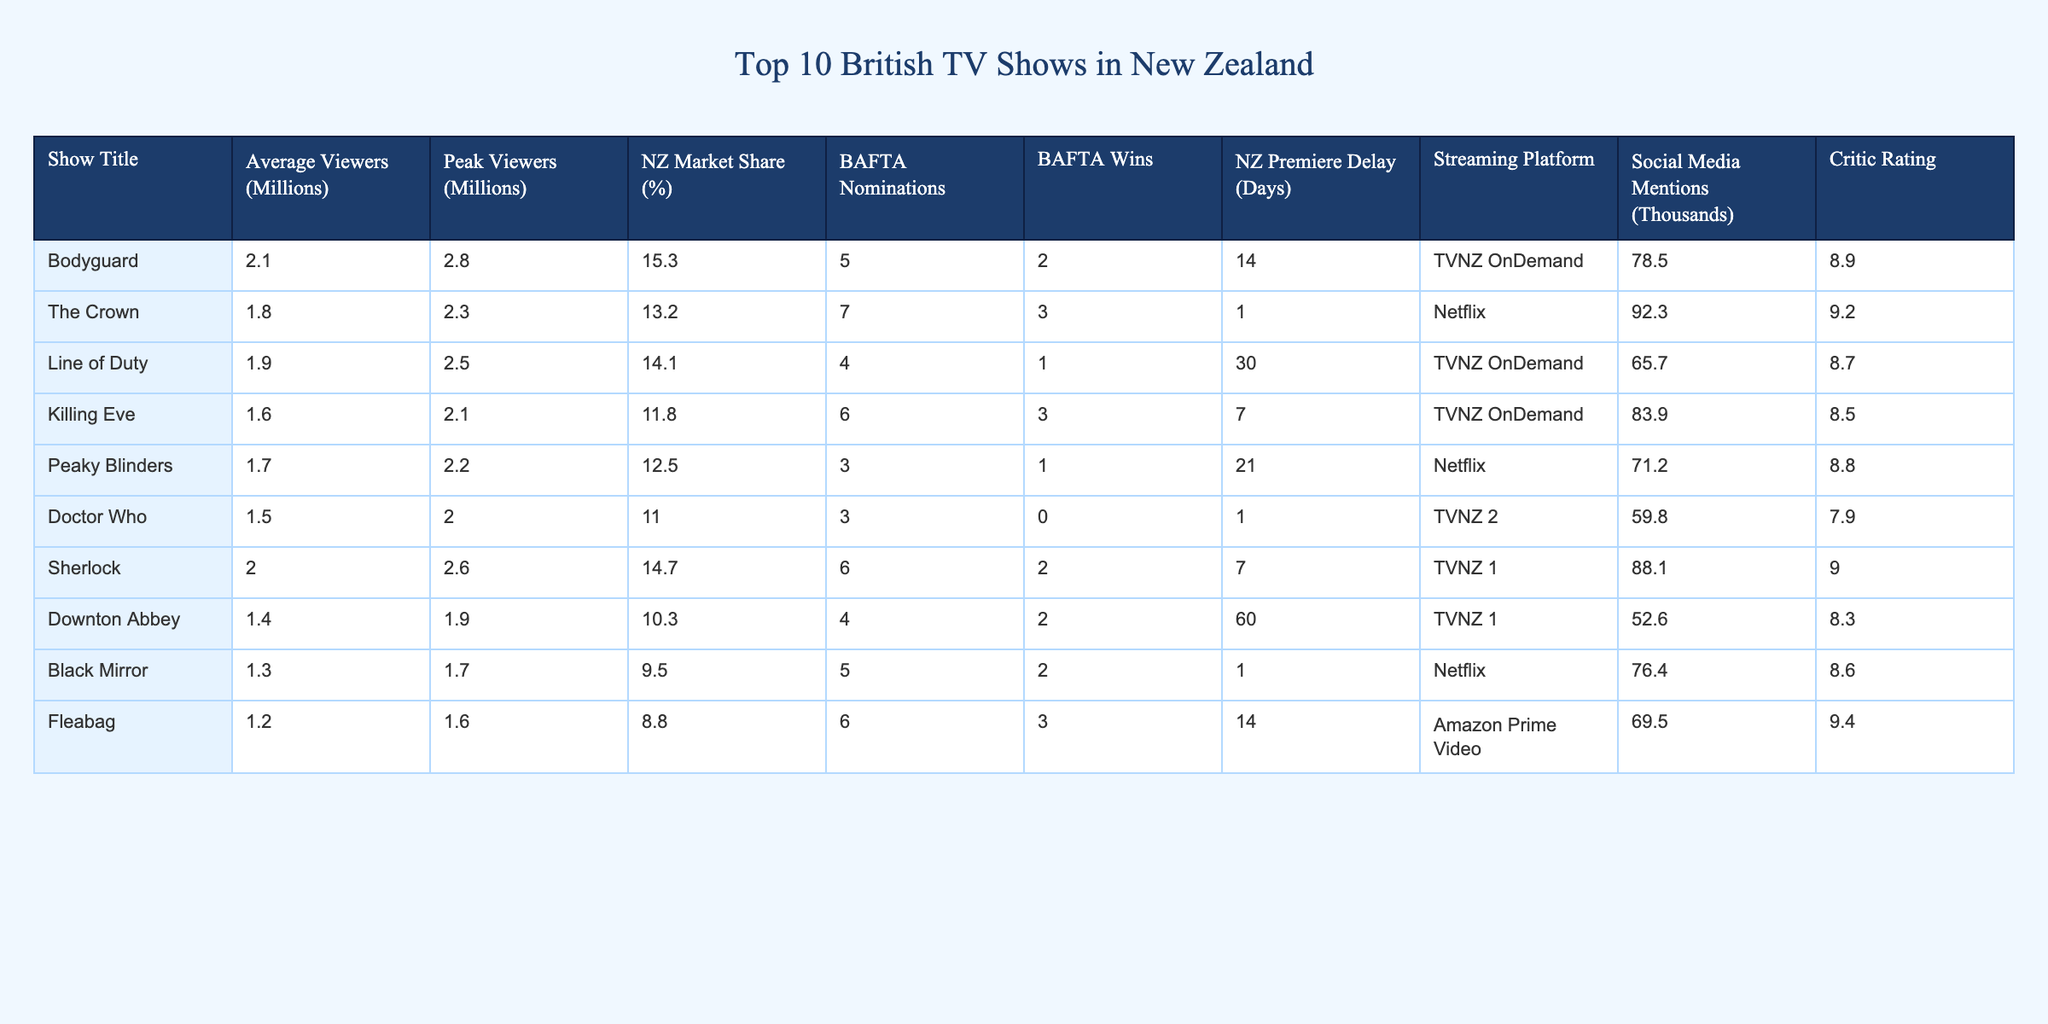What is the average viewership for "Killing Eve"? The table shows that "Killing Eve" has an average viewership of 1.6 million viewers.
Answer: 1.6 million Which show had the peak viewership of 2.8 million? According to the table, "Bodyguard" achieved the highest peak viewership with 2.8 million viewers.
Answer: Bodyguard What is the NZ market share percentage of "Peaky Blinders"? The table indicates that "Peaky Blinders" has a market share of 12.5%.
Answer: 12.5% How many BAFTA nominations did "The Crown" receive? From the table, "The Crown" received 7 BAFTA nominations.
Answer: 7 Which show has the highest critic rating? The highest critic rating in the table is for "Fleabag," which has a rating of 9.4.
Answer: Fleabag What is the total number of BAFTA wins for the shows in the table? Adding up the BAFTA wins (2 + 3 + 1 + 3 + 1 + 0 + 2 + 2 + 2 + 3) gives a total of 19 BAFTA wins for all shows combined.
Answer: 19 What is the difference in average viewers between "Doctor Who" and "Sherlock"? "Doctor Who" has 1.5 million average viewers and "Sherlock" has 2.0 million. The difference is 2.0 - 1.5 = 0.5 million viewers.
Answer: 0.5 million Did "Black Mirror" have more social media mentions than "Downton Abbey"? Looking at the table, "Black Mirror" has 76.4 thousand mentions, while "Downton Abbey" has 52.6 thousand. Yes, "Black Mirror" had more mentions.
Answer: Yes Which show has the longest NZ premiere delay, and how many days was it? "Downton Abbey" has the longest premiere delay at 60 days, according to the table.
Answer: Downton Abbey, 60 days What is the average NZ market share of all shows listed? Adding the market shares (15.3 + 13.2 + 14.1 + 11.8 + 12.5 + 11.0 + 14.7 + 10.3 + 9.5 + 8.8) gives 117.2. Dividing by the number of shows (10), the average market share is 11.72%.
Answer: 11.72% 